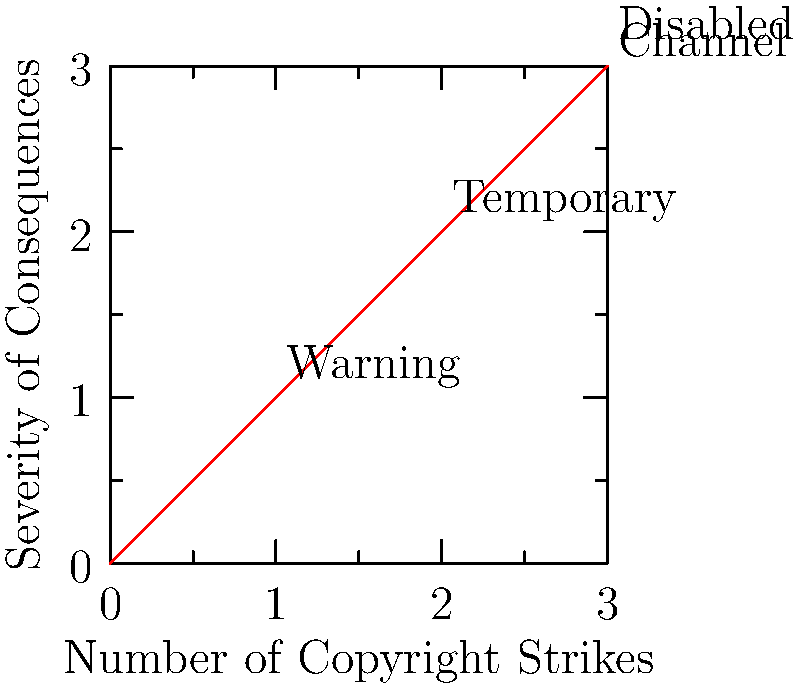Based on the graph representing YouTube's three-strike policy for copyright infringement, at which point does a channel face the most severe consequence? To answer this question, we need to analyze the graph and understand YouTube's three-strike policy:

1. The x-axis represents the number of copyright strikes, ranging from 0 to 3.
2. The y-axis represents the severity of consequences, also ranging from 0 to 3.
3. The red line shows how the consequences escalate with each strike.

Let's examine each point:

1. At 0 strikes: No consequences (0,0)
2. At 1 strike: Warning (1,1)
3. At 2 strikes: Temporary consequences (2,2), likely temporary channel restrictions
4. At 3 strikes: The highest point on the graph (3,3), labeled "Channel Disabled"

The graph clearly shows that the most severe consequence occurs at the third strike. This is when the channel faces being disabled, which is the ultimate penalty in YouTube's copyright strike system.

Therefore, the point at which a channel faces the most severe consequence is at 3 strikes.
Answer: 3 strikes 